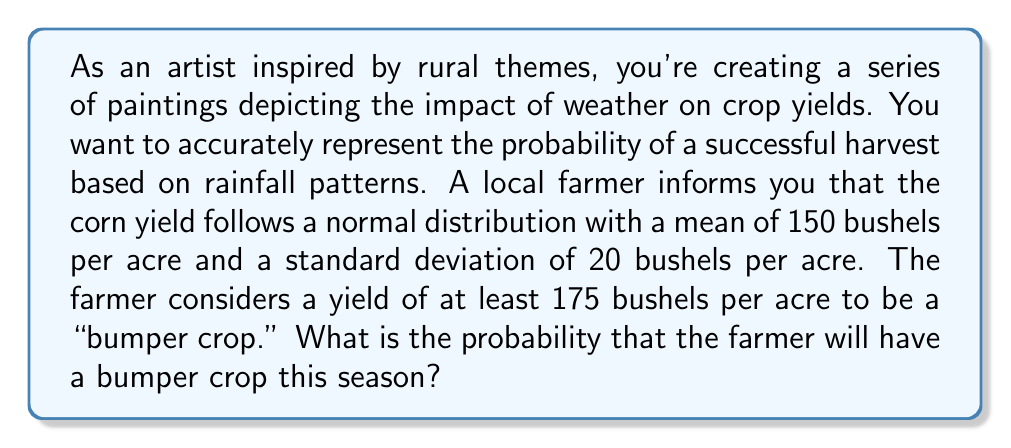Help me with this question. To solve this problem, we need to use the properties of the normal distribution and calculate the z-score for the given values. Then, we can use a standard normal distribution table or a calculator to find the probability.

Given:
- The corn yield follows a normal distribution
- Mean (μ) = 150 bushels per acre
- Standard deviation (σ) = 20 bushels per acre
- Bumper crop threshold = 175 bushels per acre

Step 1: Calculate the z-score for 175 bushels per acre.
The z-score formula is:
$$ z = \frac{x - μ}{σ} $$

Where:
x = the value we're interested in (175 bushels per acre)
μ = the mean (150 bushels per acre)
σ = the standard deviation (20 bushels per acre)

Plugging in the values:
$$ z = \frac{175 - 150}{20} = \frac{25}{20} = 1.25 $$

Step 2: Find the probability using the standard normal distribution.
We need to find P(X ≥ 175), which is equivalent to P(Z ≥ 1.25) in the standard normal distribution.

Using a standard normal distribution table or calculator, we find:
P(Z ≥ 1.25) ≈ 0.1056

This means the probability of getting a value greater than or equal to 1.25 standard deviations above the mean is approximately 0.1056 or 10.56%.
Answer: The probability that the farmer will have a bumper crop (yield of at least 175 bushels per acre) is approximately 0.1056 or 10.56%. 